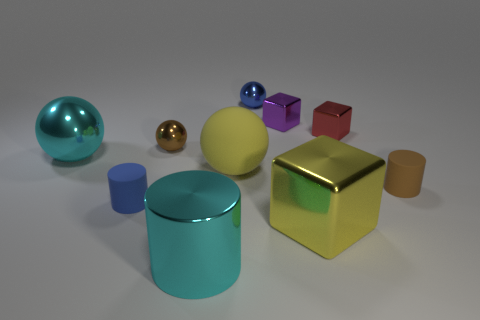Subtract all big yellow metallic blocks. How many blocks are left? 2 Subtract all yellow balls. How many balls are left? 3 Subtract 2 balls. How many balls are left? 2 Subtract all brown metal objects. Subtract all small metal things. How many objects are left? 5 Add 8 large cyan shiny cylinders. How many large cyan shiny cylinders are left? 9 Add 7 big red rubber objects. How many big red rubber objects exist? 7 Subtract 0 purple cylinders. How many objects are left? 10 Subtract all blocks. How many objects are left? 7 Subtract all brown spheres. Subtract all red cylinders. How many spheres are left? 3 